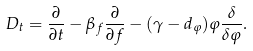<formula> <loc_0><loc_0><loc_500><loc_500>D _ { t } = \frac { \partial } { \partial t } - \beta _ { f } \frac { \partial } { \partial f } - ( \gamma - d _ { \varphi } ) \varphi \frac { \delta } { \delta \varphi } .</formula> 